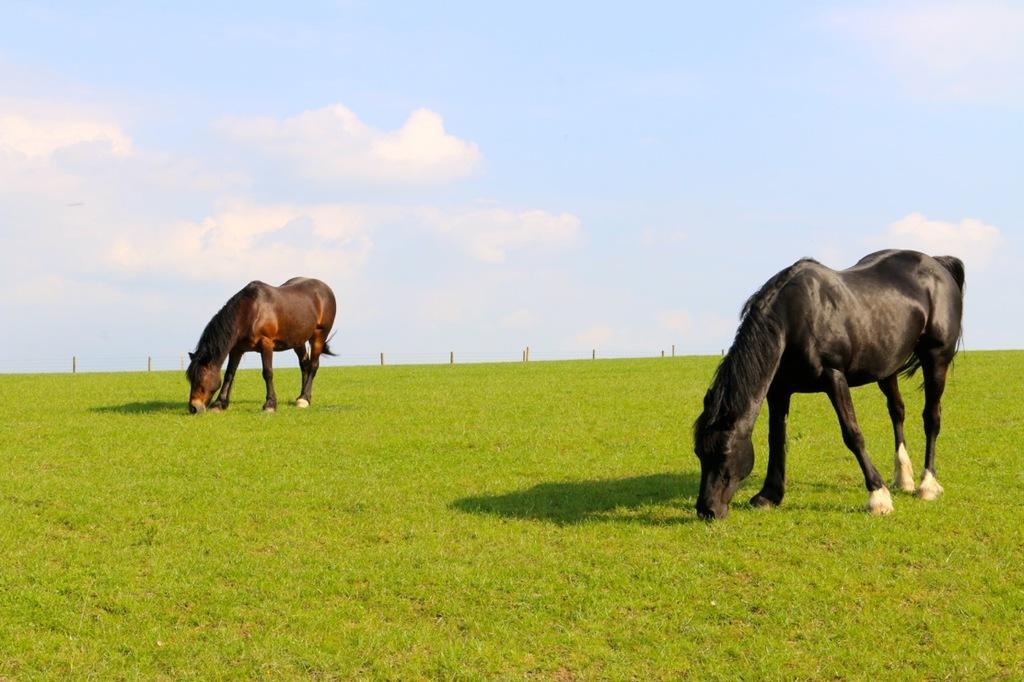Could you give a brief overview of what you see in this image? In this image there are two horses standing on the ground. They are eating grass. There is grass on the ground. Behind them there are rods on the ground. At the top there is the sky. 